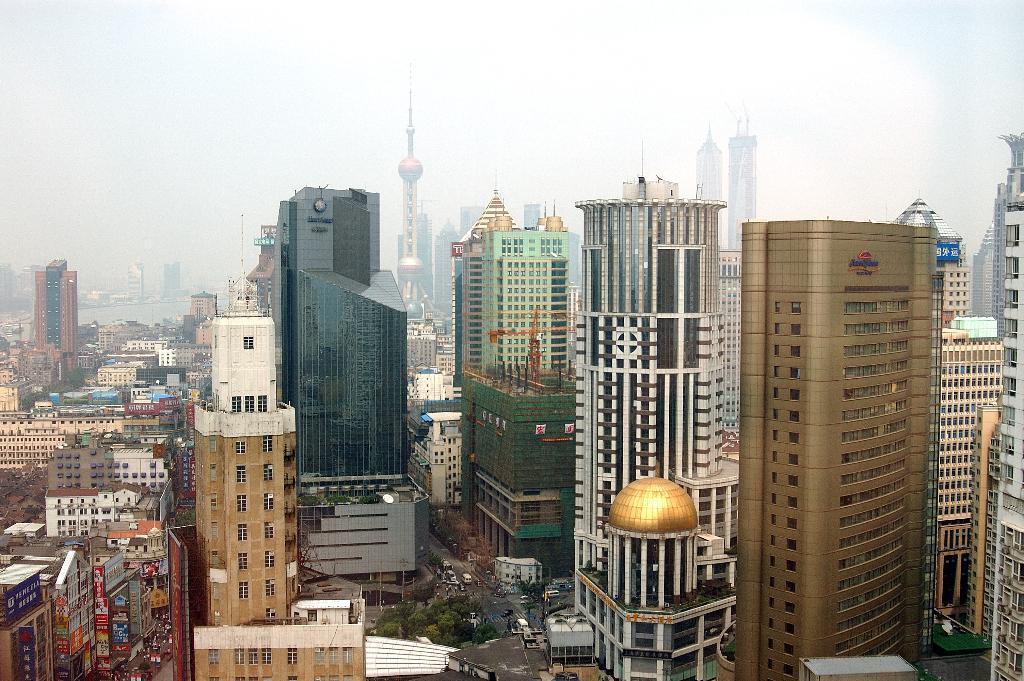Could you give a brief overview of what you see in this image? In the image there are many buildings, towers, few trees and vehicles. In the background it looks like there is some water surface on the left side. 